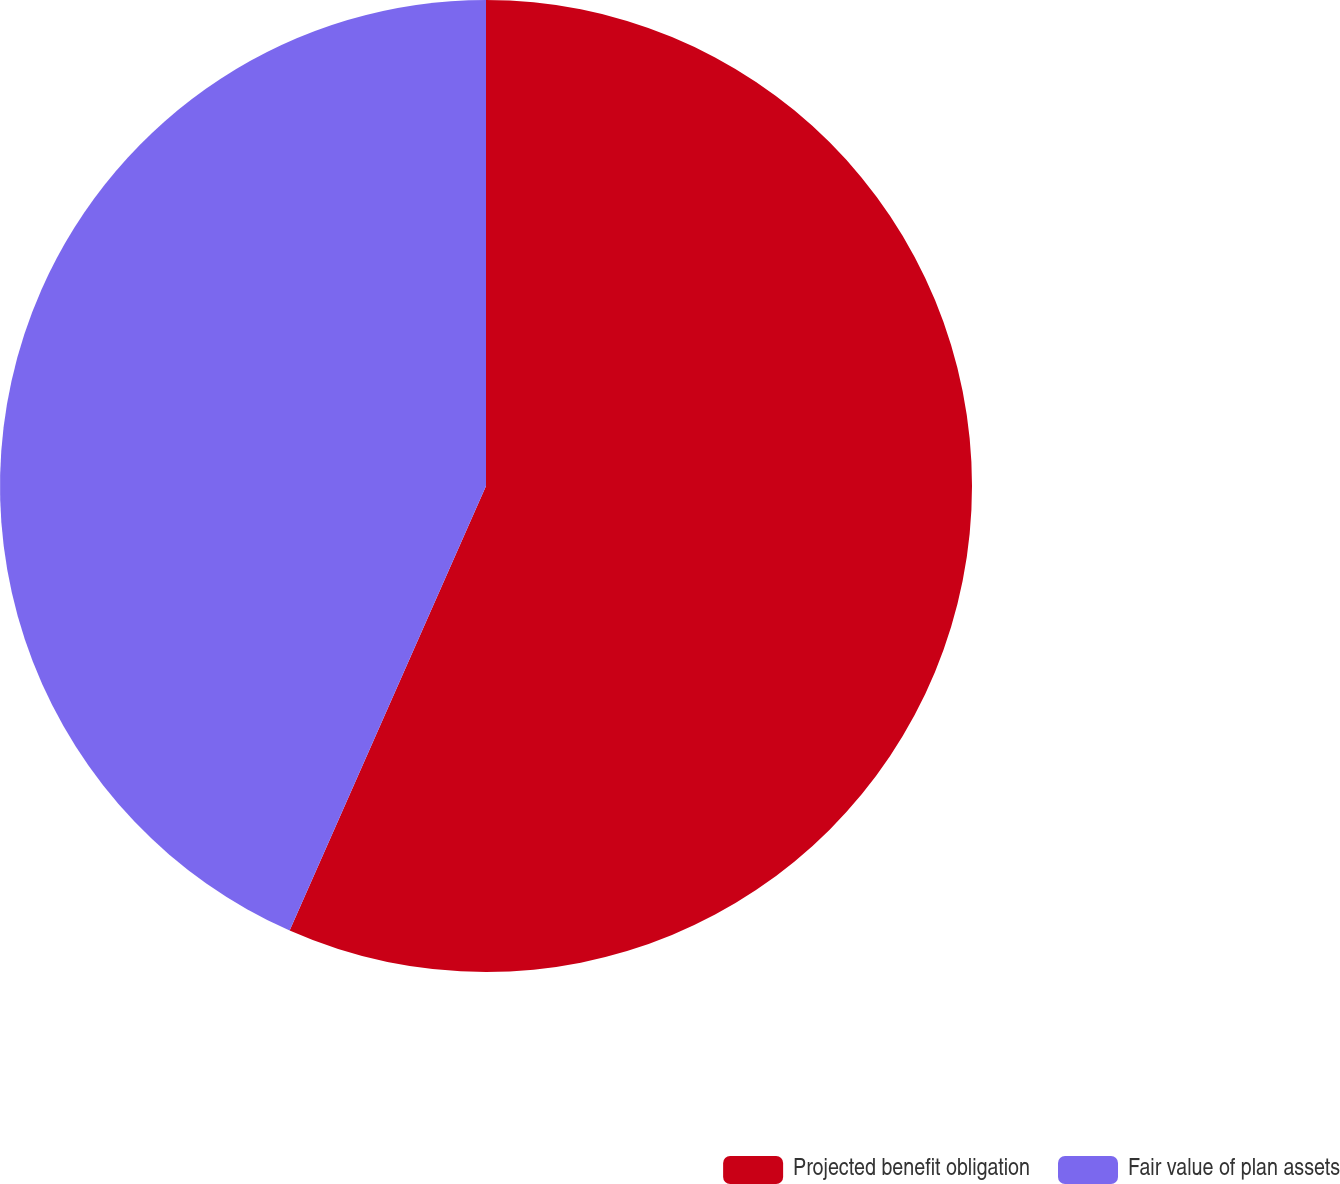Convert chart to OTSL. <chart><loc_0><loc_0><loc_500><loc_500><pie_chart><fcel>Projected benefit obligation<fcel>Fair value of plan assets<nl><fcel>56.62%<fcel>43.38%<nl></chart> 